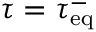Convert formula to latex. <formula><loc_0><loc_0><loc_500><loc_500>\tau = \tau _ { e q } ^ { - }</formula> 